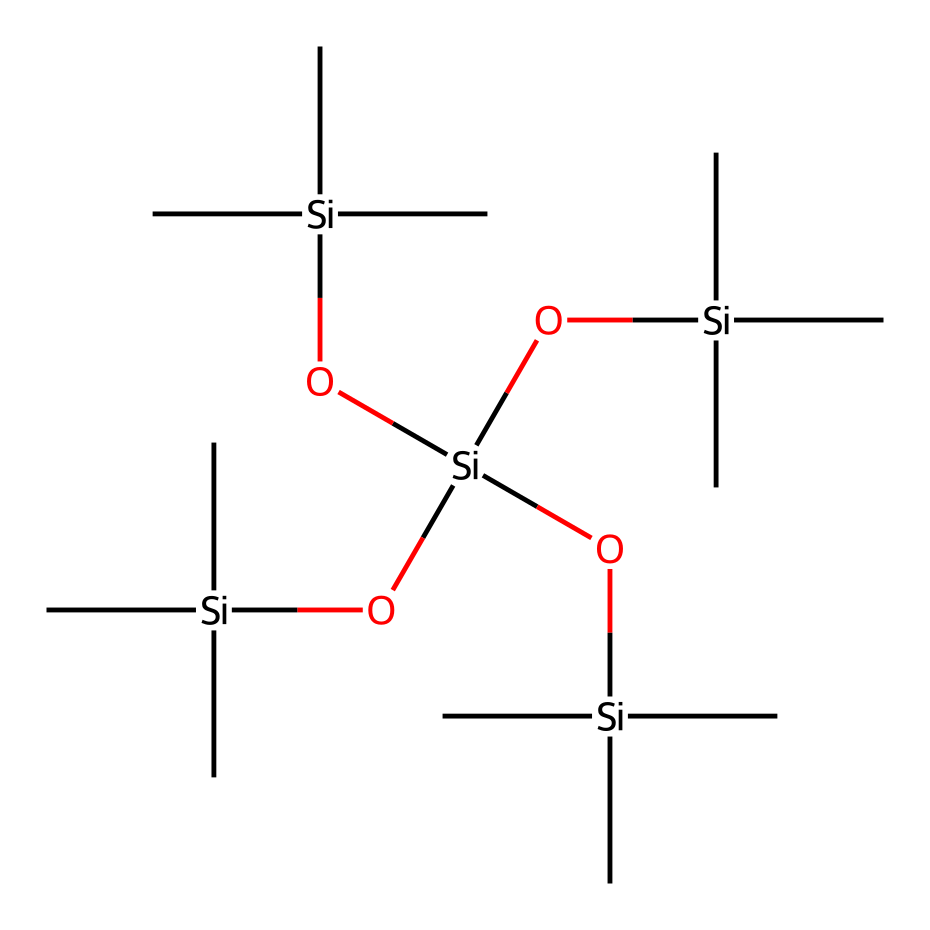what is the main functional group present in this chemical? The SMILES representation shows multiple silicon atoms bonded to oxygens and carbon chains, indicating the presence of silanol groups (-Si-OH) since each terminal Si atom is likely hypo-saturated with respect to valence; thus, they incorporate functionalities.
Answer: silanol how many silicon atoms are in the structure? By analyzing the SMILES string, we can count the silicon atoms represented by [Si]. Each instance counts towards the overall total, and in this case, it appears 5 distinct silicon atoms are noted in the structure.
Answer: 5 what is the total number of carbon atoms in this molecule? From the SMILES representation, each [Si](C)(C)C section indicates that each silicon is bonded to three carbon atoms. As there are four such [Si] sections, the calculation would be 4 * 3 = 12 carbon atoms total.
Answer: 12 does this compound likely have a hydrophobic or hydrophilic nature? Given that the structure contains multiple silicon atoms and carbon chains while also presenting silanol groups, we can reason that the hydrophilic functional groups (silanols) will dominate due to their ability to form hydrogen bonds with water, influencing the overall solubility.
Answer: hydrophilic can this compound be used in semiconductor applications? The structure's organization with repeating silicon and organic components is characteristic of photoresists, which are utilized in lithography processes within semiconductor manufacturing to transfer patterns onto substrates.
Answer: yes which type of bonding is prevalent in this organosilicon compound? The molecular structure showcases substantial covalent bonding, specifically Si-C and Si-O bonds, which are typical in organosilicon compounds, resulting in a robust framework critical for stability and functionality in applications such as photoresists.
Answer: covalent 